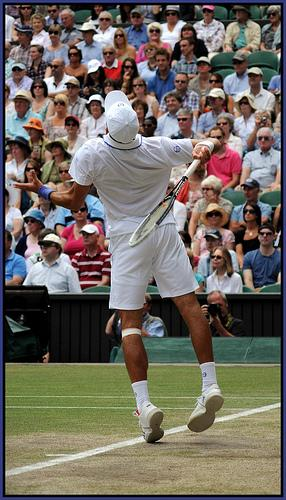Count how many men are wearing different color shirts in the image. A man in red shirt with white stripes, one in pink, one in orange, one in white, one in blue. Identify the objects that people are holding in their hands in the image. Some men are holding cameras and the tennis player has a black and white racket. Provide a detailed description of the tennis player and his attire. The tennis player is a man wearing all white, including a hat, shirt, shorts, socks, and shoes. He has a white wristband and a white band around his knee. How many people are shown as spectators in the image and what are they doing? There are nine spectators watching the game, some wearing sunglasses and taking photos. Mention the colors of the different shirts worn by the spectators. Red, pink, orange, white, and blue. List the accessories worn by the tennis player and the color of each. White hat, white wristband, white band around the knee, and white shoes. Describe the appearance of the two photographers shown in the image. One is a balding man and the other is a man wearing a white shirt and ballcap. What is the main activity being depicted in the image? A man in white playing tennis on a court. What are the common features that some people in the image have? Some people are wearing sunglasses and others are wearing hats or caps. Briefly describe the tennis court and the surroundings in the image. The tennis court has white lines, brown and green coloring, and is near a green fence. There are spectators around the court wearing various colored clothes. How many kids in red baseball hats can you locate in the audience? This instruction is misleading because there is no reference to kids wearing red baseball hats in the image information. Viewers would be trying to find objects that are not there in the image. Observe the tennis ball in mid-air, captured just as the player is about to hit it. This instruction is misleading because there is no mention of a tennis ball being in mid-air or the player about to hit it in the image information provided. Viewers would be searching for an object that does not exist in the image. In the middle of the crowd, there's a dog lying on the ground, seemingly uninterested in the tennis match.  This instruction is misleading because there is no mention of a dog lying on the ground in the image information. So, the viewer would probably try looking for an object that is not present in the image. Please examine the bright red sports car parked behind the green fence. This instruction is misleading because there is no reference to any sports car, red or otherwise, parked behind the green fence in the image information. The viewer would try looking for an object that does not exist in the image. Notice how the person wearing the purple dress in the bottom left of the image seems to be enjoying the game. This instruction is misleading because none of the listed objects describes a person wearing a purple dress in the image. The viewer would be searching for an object that doesn't exist. Can you identify the flying bird in the top right corner of the image? This instruction is misleading because there is no mention of any bird in the image, so the viewer would try looking for a nonexistent object. 